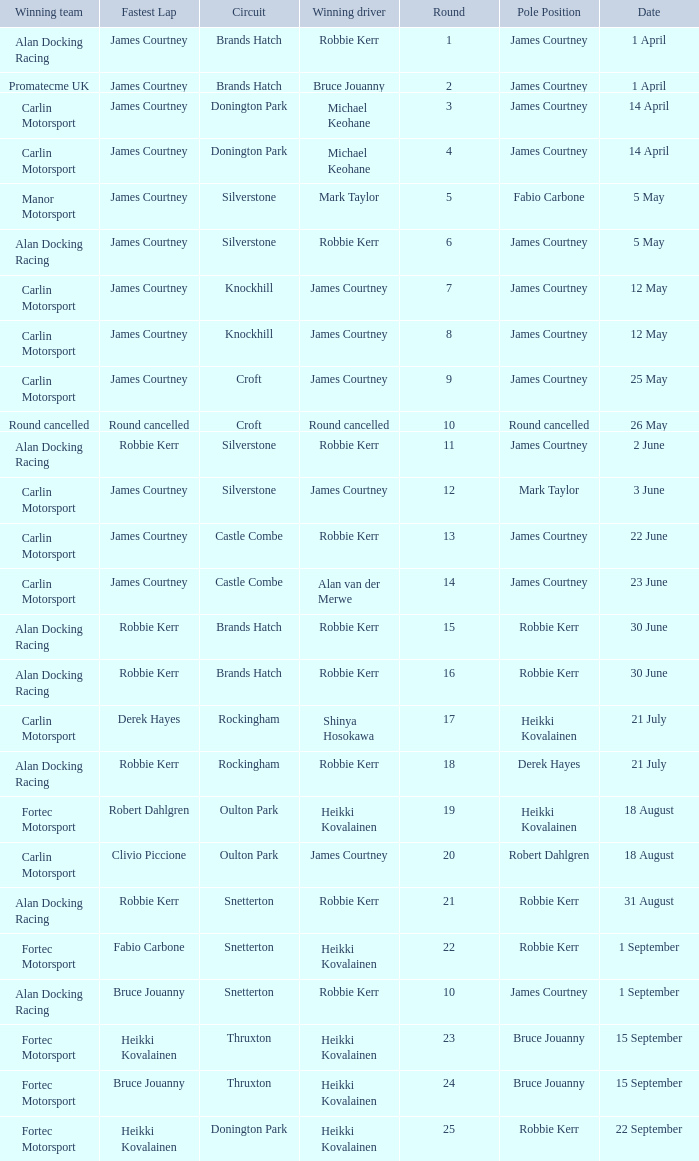How many rounds have Fabio Carbone for fastest lap? 1.0. 